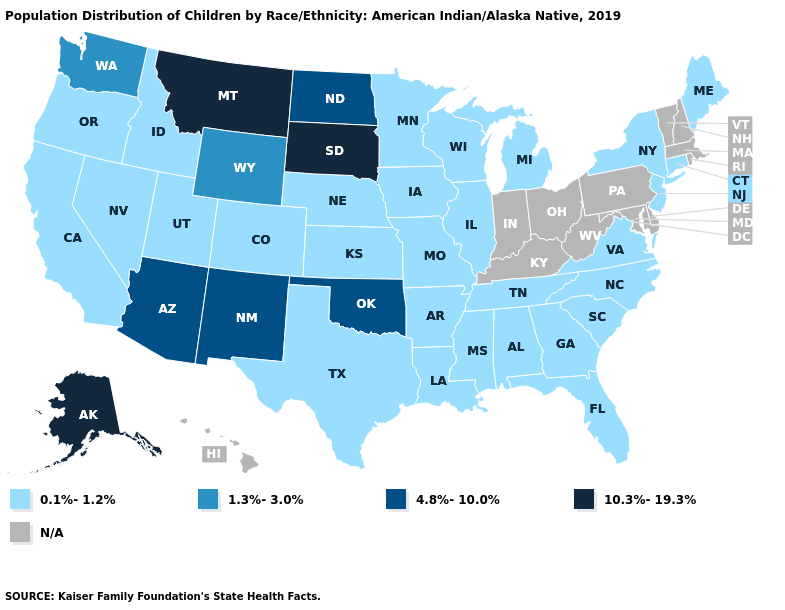Which states hav the highest value in the MidWest?
Keep it brief. South Dakota. Name the states that have a value in the range N/A?
Answer briefly. Delaware, Hawaii, Indiana, Kentucky, Maryland, Massachusetts, New Hampshire, Ohio, Pennsylvania, Rhode Island, Vermont, West Virginia. Does the first symbol in the legend represent the smallest category?
Concise answer only. Yes. Among the states that border Texas , which have the lowest value?
Keep it brief. Arkansas, Louisiana. Name the states that have a value in the range N/A?
Keep it brief. Delaware, Hawaii, Indiana, Kentucky, Maryland, Massachusetts, New Hampshire, Ohio, Pennsylvania, Rhode Island, Vermont, West Virginia. What is the value of New Jersey?
Be succinct. 0.1%-1.2%. Which states have the highest value in the USA?
Concise answer only. Alaska, Montana, South Dakota. Name the states that have a value in the range 10.3%-19.3%?
Answer briefly. Alaska, Montana, South Dakota. What is the value of Tennessee?
Short answer required. 0.1%-1.2%. Name the states that have a value in the range 10.3%-19.3%?
Write a very short answer. Alaska, Montana, South Dakota. What is the value of New Mexico?
Be succinct. 4.8%-10.0%. What is the value of Illinois?
Keep it brief. 0.1%-1.2%. Name the states that have a value in the range 0.1%-1.2%?
Quick response, please. Alabama, Arkansas, California, Colorado, Connecticut, Florida, Georgia, Idaho, Illinois, Iowa, Kansas, Louisiana, Maine, Michigan, Minnesota, Mississippi, Missouri, Nebraska, Nevada, New Jersey, New York, North Carolina, Oregon, South Carolina, Tennessee, Texas, Utah, Virginia, Wisconsin. Name the states that have a value in the range N/A?
Short answer required. Delaware, Hawaii, Indiana, Kentucky, Maryland, Massachusetts, New Hampshire, Ohio, Pennsylvania, Rhode Island, Vermont, West Virginia. What is the lowest value in the USA?
Short answer required. 0.1%-1.2%. 